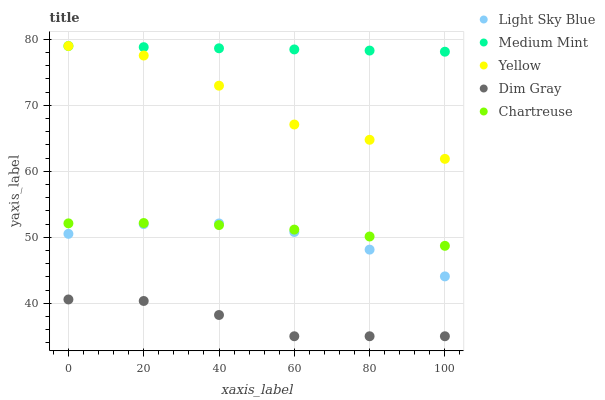Does Dim Gray have the minimum area under the curve?
Answer yes or no. Yes. Does Medium Mint have the maximum area under the curve?
Answer yes or no. Yes. Does Light Sky Blue have the minimum area under the curve?
Answer yes or no. No. Does Light Sky Blue have the maximum area under the curve?
Answer yes or no. No. Is Medium Mint the smoothest?
Answer yes or no. Yes. Is Yellow the roughest?
Answer yes or no. Yes. Is Dim Gray the smoothest?
Answer yes or no. No. Is Dim Gray the roughest?
Answer yes or no. No. Does Dim Gray have the lowest value?
Answer yes or no. Yes. Does Light Sky Blue have the lowest value?
Answer yes or no. No. Does Yellow have the highest value?
Answer yes or no. Yes. Does Light Sky Blue have the highest value?
Answer yes or no. No. Is Light Sky Blue less than Medium Mint?
Answer yes or no. Yes. Is Yellow greater than Chartreuse?
Answer yes or no. Yes. Does Chartreuse intersect Light Sky Blue?
Answer yes or no. Yes. Is Chartreuse less than Light Sky Blue?
Answer yes or no. No. Is Chartreuse greater than Light Sky Blue?
Answer yes or no. No. Does Light Sky Blue intersect Medium Mint?
Answer yes or no. No. 